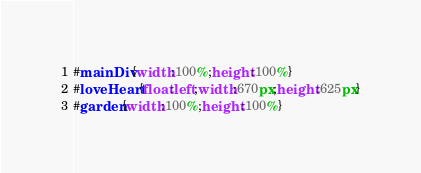Convert code to text. <code><loc_0><loc_0><loc_500><loc_500><_CSS_>#mainDiv{width:100%;height:100%}
#loveHeart{float:left;width:670px;height:625px}
#garden{width:100%;height:100%}</code> 